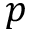<formula> <loc_0><loc_0><loc_500><loc_500>p</formula> 